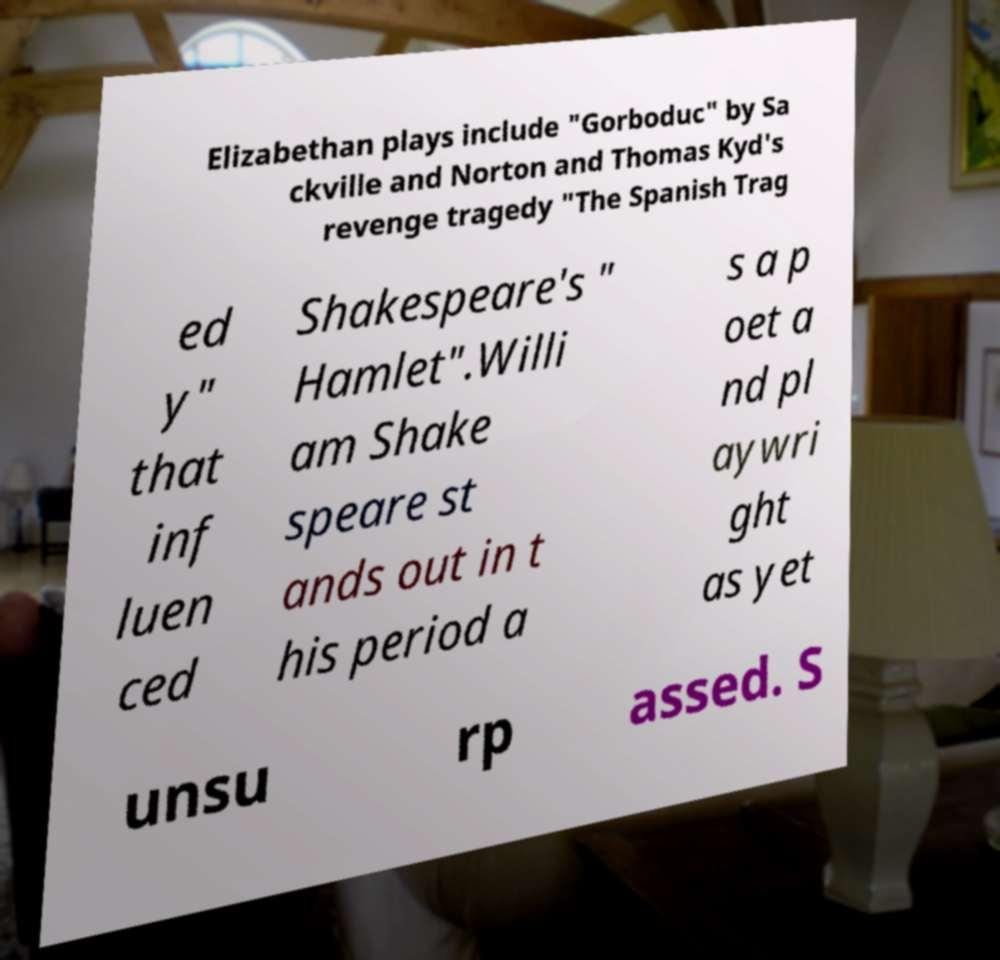Please identify and transcribe the text found in this image. Elizabethan plays include "Gorboduc" by Sa ckville and Norton and Thomas Kyd's revenge tragedy "The Spanish Trag ed y" that inf luen ced Shakespeare's " Hamlet".Willi am Shake speare st ands out in t his period a s a p oet a nd pl aywri ght as yet unsu rp assed. S 